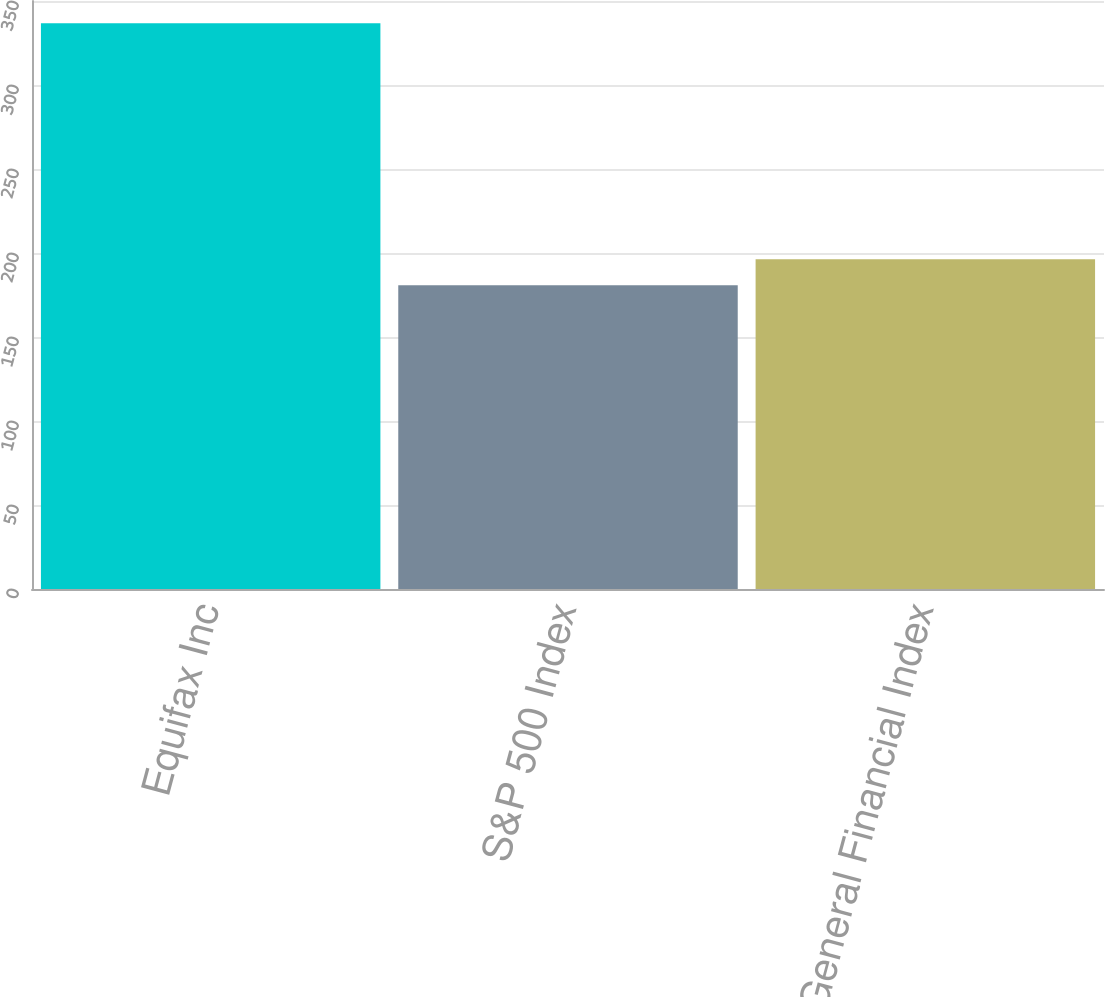Convert chart. <chart><loc_0><loc_0><loc_500><loc_500><bar_chart><fcel>Equifax Inc<fcel>S&P 500 Index<fcel>DJ US General Financial Index<nl><fcel>336.79<fcel>180.75<fcel>196.35<nl></chart> 